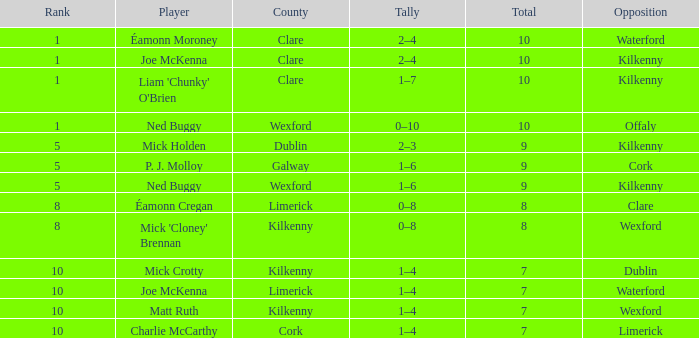In which county does a player named joe mckenna have a rank higher than 8? Limerick. 